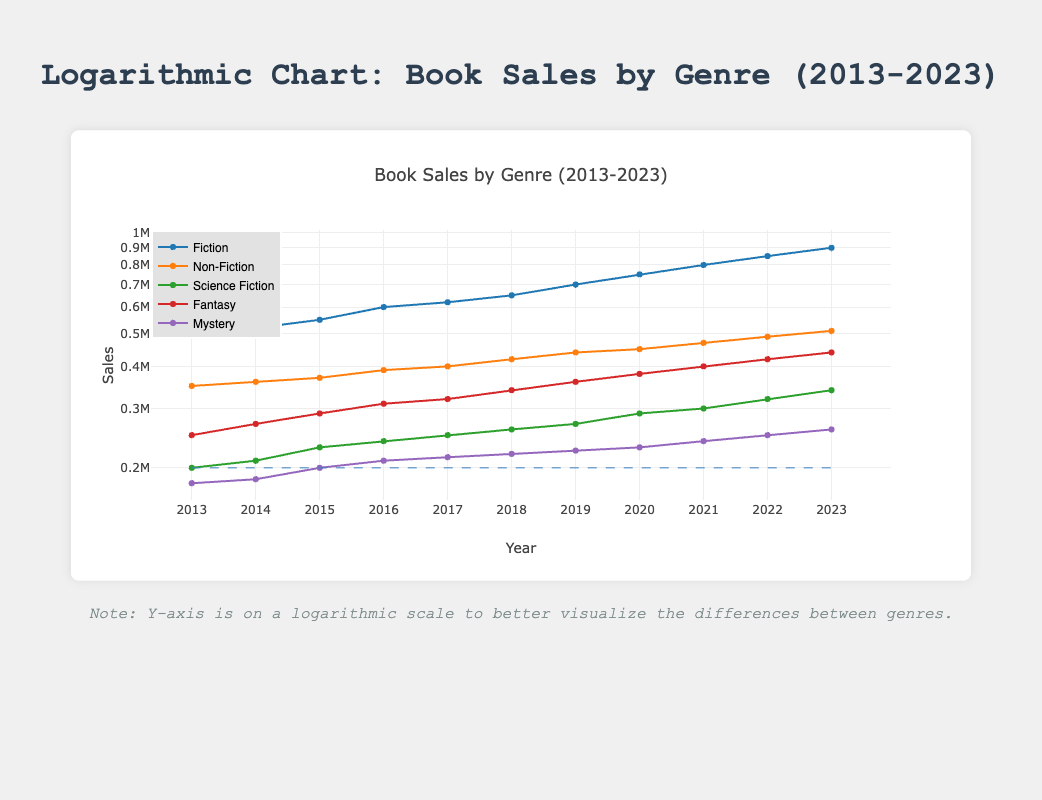What was the total number of Fiction books sold in 2015? In 2015, the number of Fiction books sold is directly provided in the table. By locating the values for the year 2015, I find Fiction is 550,000.
Answer: 550000 Which genre had the highest sales in 2020? The table lists the sales figures for each genre in 2020. Fiction has 750,000, Non-Fiction has 450,000, Science Fiction has 290,000, Fantasy has 380,000, and Mystery has 230,000. The highest sales figure among these is for Fiction at 750,000.
Answer: Fiction Did Non-Fiction sales increase every year from 2013 to 2023? Looking at the Non-Fiction sales figures from 2013 to 2023, we see a steady increase starting from 350,000 in 2013 to 510,000 in 2023, confirming that it increased every year without a drop.
Answer: Yes What was the percentage increase in Fantasy book sales from 2013 to 2023? The Fantasy sales in 2013 were 250,000 and in 2023 it was 440,000. To find the percentage increase, I subtract the initial value from the final value: (440,000 - 250,000) = 190,000. Then, to find the percentage, I divide by the initial value: (190,000 / 250,000) * 100 = 76%.
Answer: 76% What genre had the least number of sales in 2019? Examining the values for each genre in 2019, Fiction has 700,000, Non-Fiction has 440,000, Science Fiction has 270,000, Fantasy has 360,000, and Mystery has 225,000. Among these, the lowest sales figure is for Mystery at 225,000.
Answer: Mystery Calculate the average number of Science Fiction books sold from 2013 to 2023. The sales figures for Science Fiction from 2013 to 2023 are 200,000, 210,000, 230,000, 240,000, 250,000, 260,000, 270,000, 290,000, 300,000, 320,000, and 340,000. There are 11 data points, so I add them up: 200,000 + 210,000 + 230,000 + 240,000 + 250,000 + 260,000 + 270,000 + 290,000 + 300,000 + 320,000 + 340,000 = 2,920,000. Then, I divide by 11: 2,920,000 / 11 = approximately 265,454.5.
Answer: 265454.5 Was there a year where Fiction sales were less than 600,000? By checking the sales figures for Fiction from the years provided, it can be seen that in 2013 (500,000), 2014 (520,000), and 2015 (550,000) were all below 600,000. Thus, there were indeed years with less than 600,000 sales.
Answer: Yes What is the difference in sales between the highest and lowest genres in 2022? In 2022, Fiction sales were 850,000 and Mystery sales were 250,000. The difference is calculated by subtracting the lower value from the higher value: 850,000 - 250,000 = 600,000.
Answer: 600000 